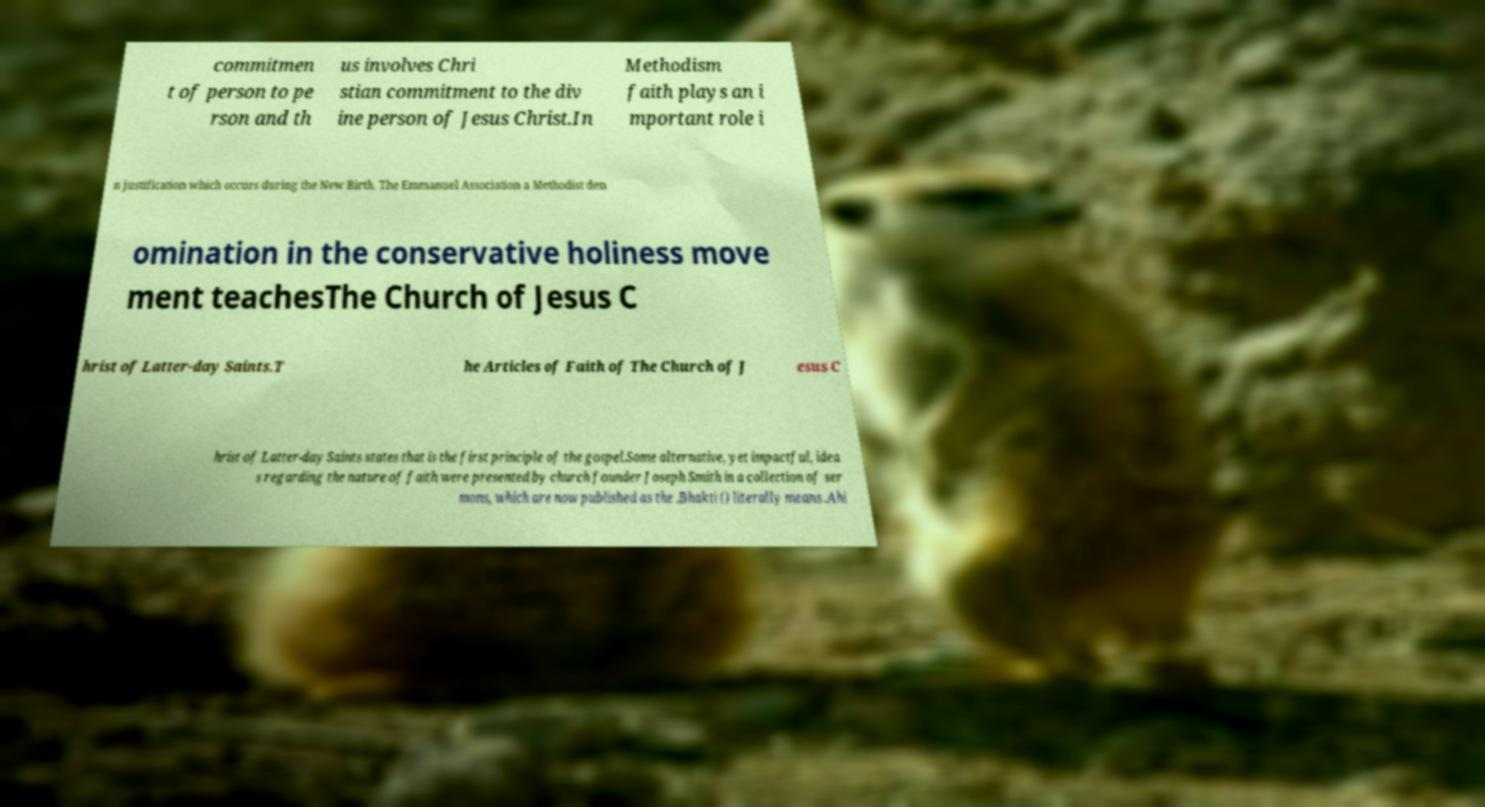Could you extract and type out the text from this image? commitmen t of person to pe rson and th us involves Chri stian commitment to the div ine person of Jesus Christ.In Methodism faith plays an i mportant role i n justification which occurs during the New Birth. The Emmanuel Association a Methodist den omination in the conservative holiness move ment teachesThe Church of Jesus C hrist of Latter-day Saints.T he Articles of Faith of The Church of J esus C hrist of Latter-day Saints states that is the first principle of the gospel.Some alternative, yet impactful, idea s regarding the nature of faith were presented by church founder Joseph Smith in a collection of ser mons, which are now published as the .Bhakti () literally means .Ahi 